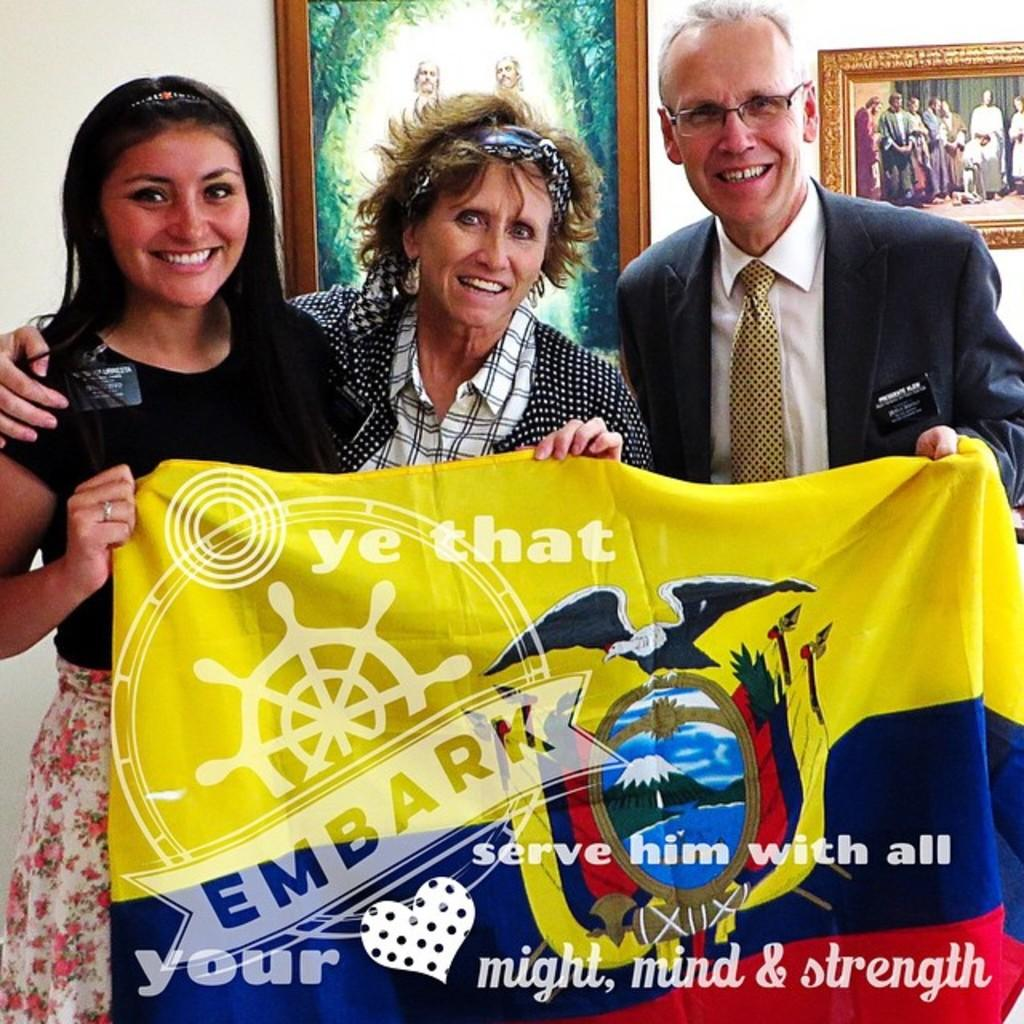Who or what can be seen in the image? There are persons in the image. What are the persons doing in the image? The persons are on the floor and holding advertisements in their hands. What can be seen in the background of the image? There are wall hangings in the background of the image. How are the wall hangings positioned in the image? The wall hangings are attached to the wall. What type of lettuce can be seen growing on the wall in the image? There is no lettuce present in the image, and the wall hangings are not related to growing plants. 